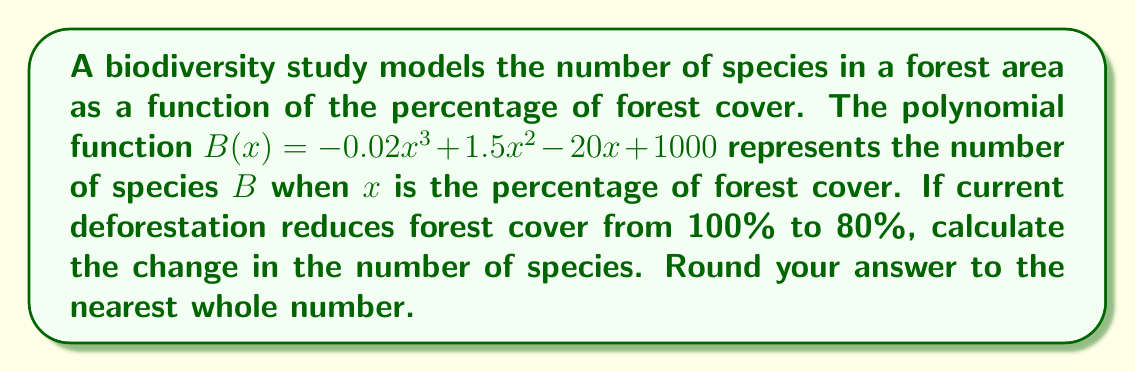What is the answer to this math problem? To solve this problem, we need to follow these steps:

1) Calculate $B(100)$ to find the number of species at 100% forest cover:
   $$B(100) = -0.02(100)^3 + 1.5(100)^2 - 20(100) + 1000$$
   $$= -20000 + 15000 - 2000 + 1000 = -6000$$

2) Calculate $B(80)$ to find the number of species at 80% forest cover:
   $$B(80) = -0.02(80)^3 + 1.5(80)^2 - 20(80) + 1000$$
   $$= -10240 + 9600 - 1600 + 1000 = -1240$$

3) Calculate the change in the number of species:
   Change = $B(80) - B(100) = -1240 - (-6000) = 4760$

4) Round to the nearest whole number:
   4760 rounds to 4760

The positive change indicates an increase in biodiversity as forest cover decreases from 100% to 80%. This counterintuitive result could represent a scenario where moderate deforestation initially increases habitat diversity, supporting more species. However, further deforestation would likely lead to biodiversity loss.
Answer: 4760 species 